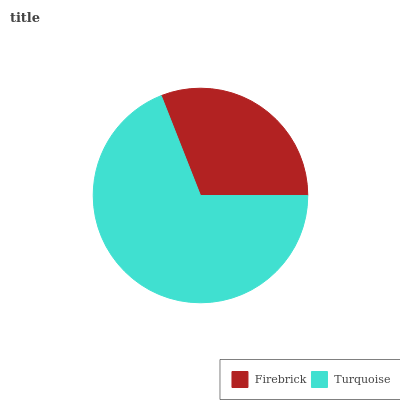Is Firebrick the minimum?
Answer yes or no. Yes. Is Turquoise the maximum?
Answer yes or no. Yes. Is Turquoise the minimum?
Answer yes or no. No. Is Turquoise greater than Firebrick?
Answer yes or no. Yes. Is Firebrick less than Turquoise?
Answer yes or no. Yes. Is Firebrick greater than Turquoise?
Answer yes or no. No. Is Turquoise less than Firebrick?
Answer yes or no. No. Is Turquoise the high median?
Answer yes or no. Yes. Is Firebrick the low median?
Answer yes or no. Yes. Is Firebrick the high median?
Answer yes or no. No. Is Turquoise the low median?
Answer yes or no. No. 